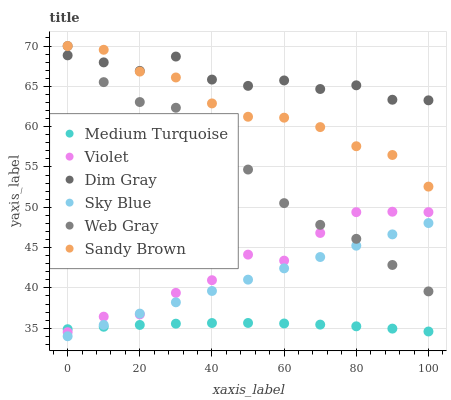Does Medium Turquoise have the minimum area under the curve?
Answer yes or no. Yes. Does Dim Gray have the maximum area under the curve?
Answer yes or no. Yes. Does Web Gray have the minimum area under the curve?
Answer yes or no. No. Does Web Gray have the maximum area under the curve?
Answer yes or no. No. Is Sky Blue the smoothest?
Answer yes or no. Yes. Is Dim Gray the roughest?
Answer yes or no. Yes. Is Web Gray the smoothest?
Answer yes or no. No. Is Web Gray the roughest?
Answer yes or no. No. Does Sky Blue have the lowest value?
Answer yes or no. Yes. Does Web Gray have the lowest value?
Answer yes or no. No. Does Sandy Brown have the highest value?
Answer yes or no. Yes. Does Medium Turquoise have the highest value?
Answer yes or no. No. Is Medium Turquoise less than Sandy Brown?
Answer yes or no. Yes. Is Sandy Brown greater than Violet?
Answer yes or no. Yes. Does Web Gray intersect Sky Blue?
Answer yes or no. Yes. Is Web Gray less than Sky Blue?
Answer yes or no. No. Is Web Gray greater than Sky Blue?
Answer yes or no. No. Does Medium Turquoise intersect Sandy Brown?
Answer yes or no. No. 